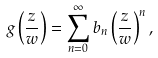Convert formula to latex. <formula><loc_0><loc_0><loc_500><loc_500>g \left ( \frac { z } { w } \right ) = \sum _ { n = 0 } ^ { \infty } b _ { n } \left ( \frac { z } { w } \right ) ^ { n } ,</formula> 